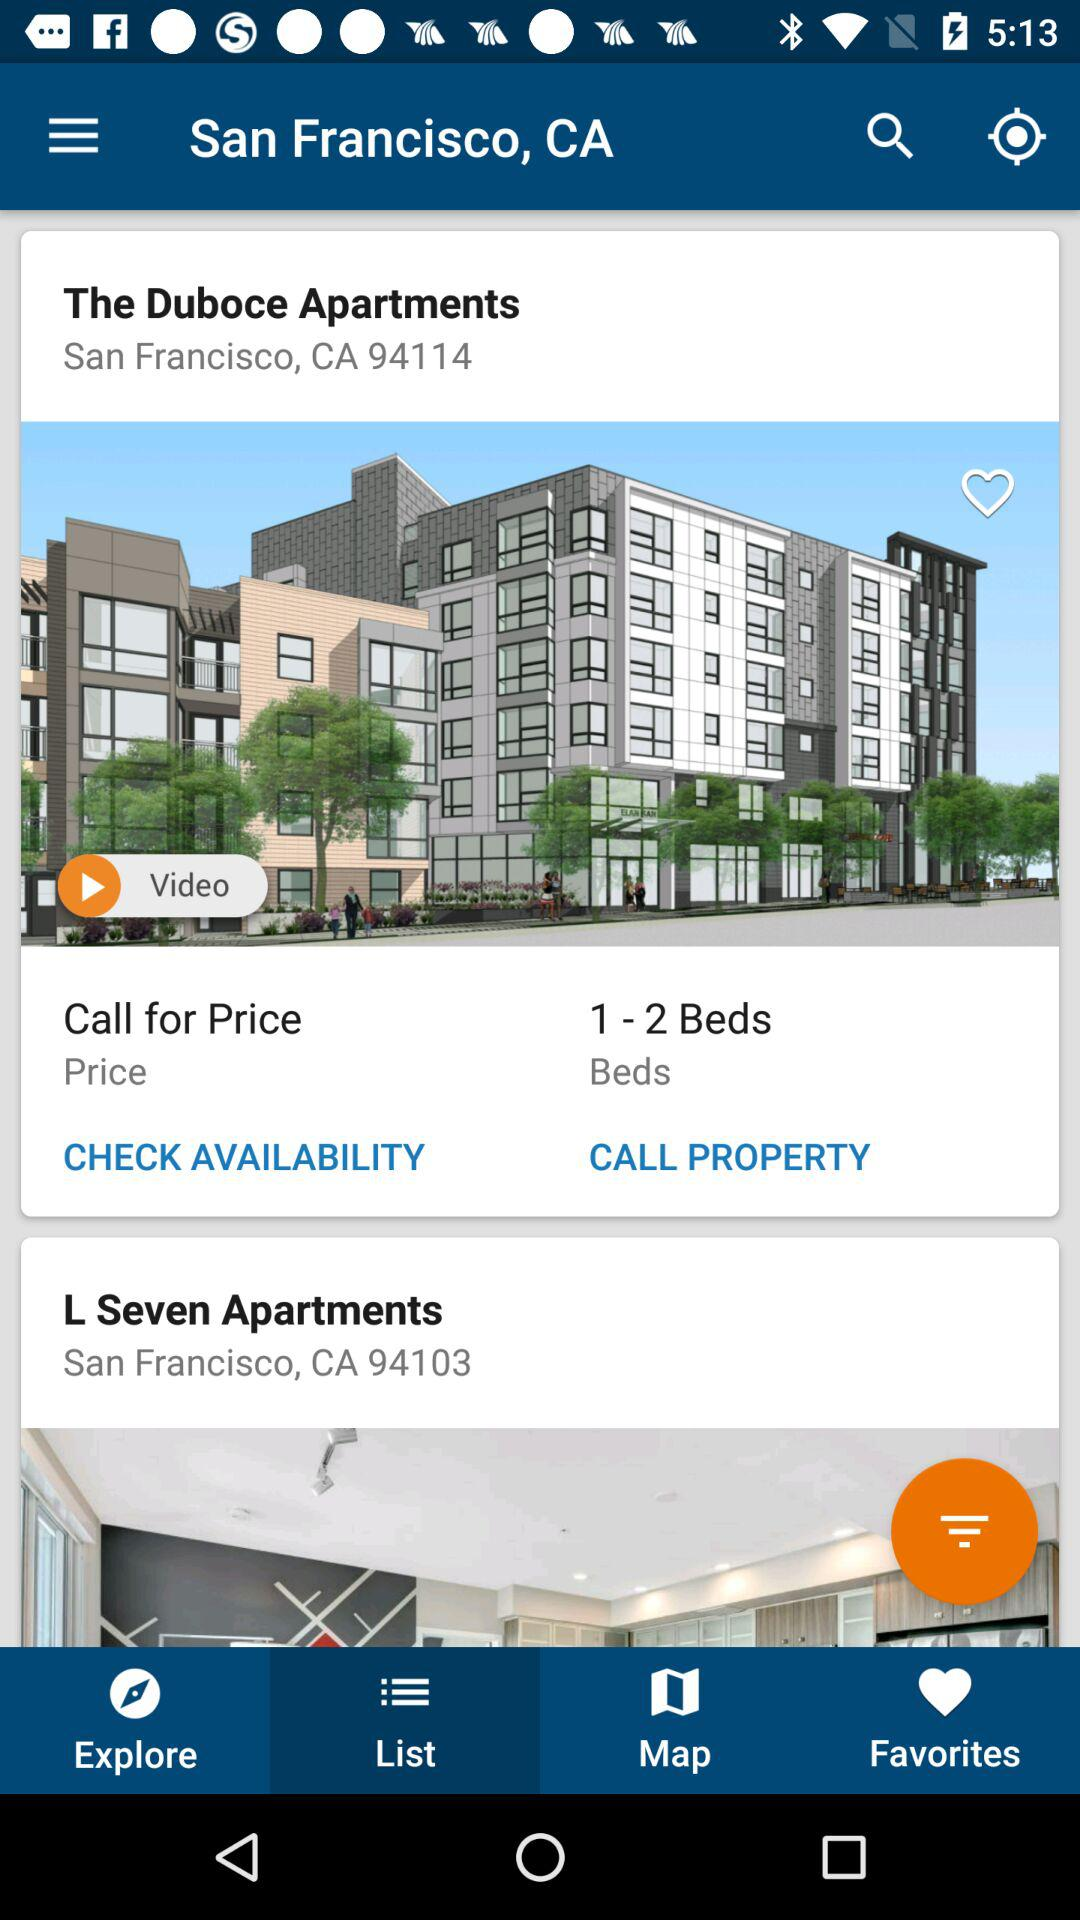How many beds are available in "The Duboce Apartments"? There are 1 to 2 beds available in "The Duboce Apartments". 